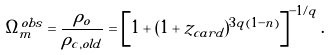Convert formula to latex. <formula><loc_0><loc_0><loc_500><loc_500>\Omega _ { m } ^ { o b s } = \frac { \rho _ { o } } { \rho _ { c , o l d } } = \left [ 1 + ( 1 + z _ { c a r d } ) ^ { 3 q ( 1 - n ) } \right ] ^ { - { 1 / q } } .</formula> 